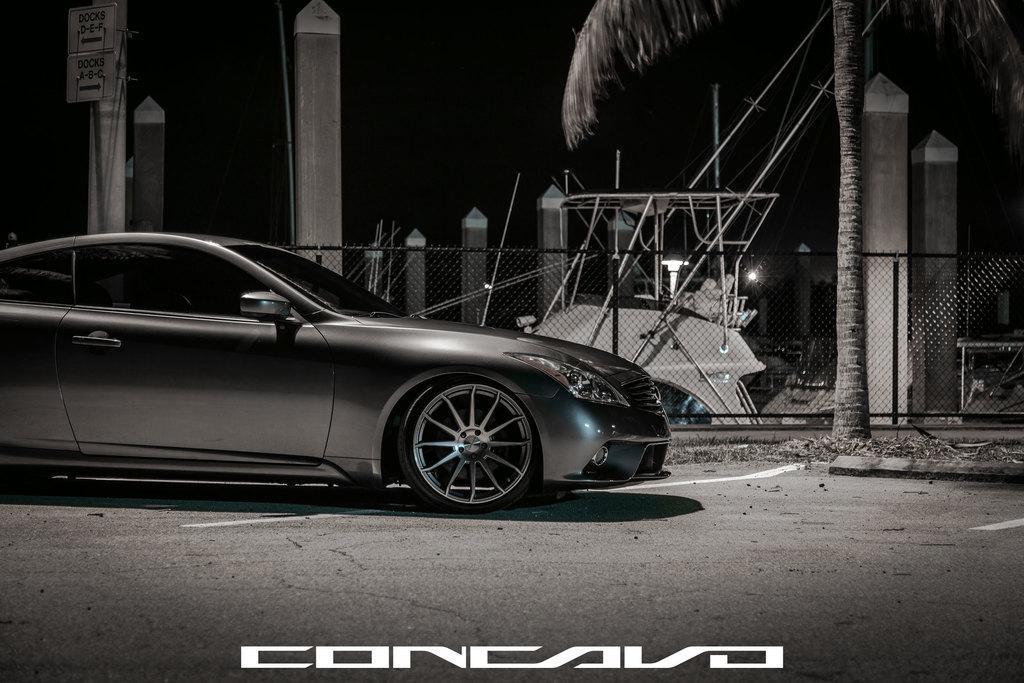Describe this image in one or two sentences. In this image we can see a car on the road, there is a tree, fence, few dollars, an object, a board to the pillar and the sky in the background. 